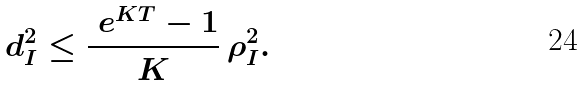<formula> <loc_0><loc_0><loc_500><loc_500>d _ { I } ^ { 2 } \leq \frac { \ e ^ { K T } - 1 } { K } \, \rho _ { I } ^ { 2 } .</formula> 